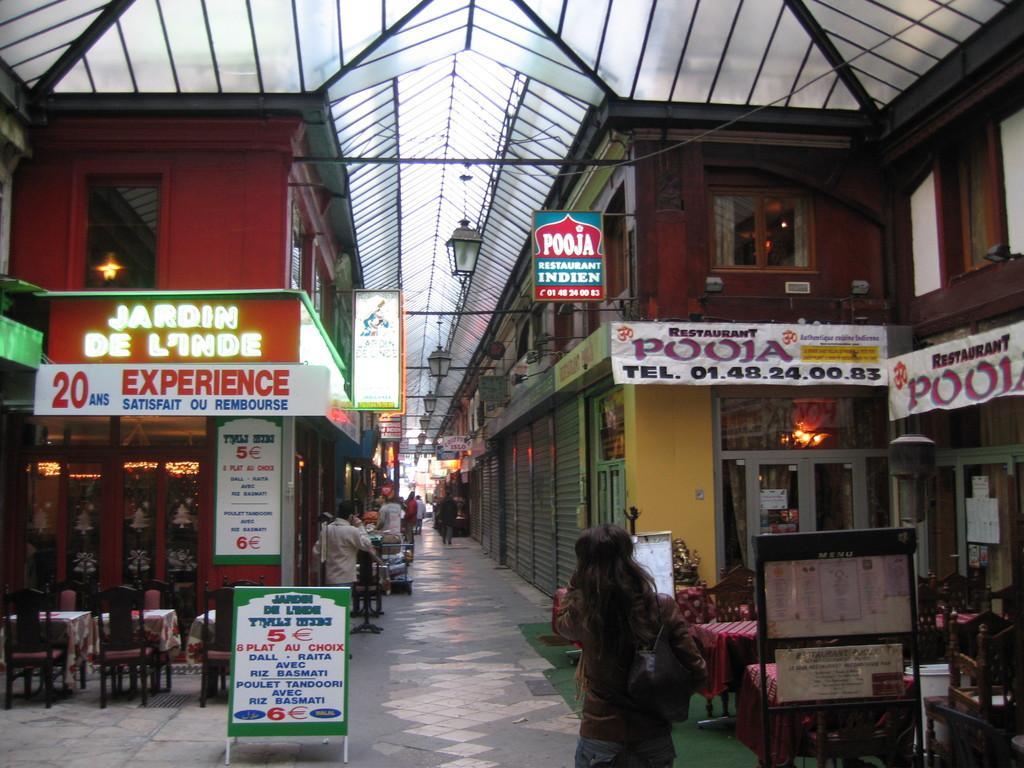Describe this image in one or two sentences. In this image on the right side and left side there are some stores, shutters and some persons are walking and also there are some boards. On the boards there is some text and on the left side there are some chairs and a board, on the board there is text. On the right side there are some chairs, tables and some other objects. In the background there are some persons who are walking, in the center there are some lights and shutters. At the top of the image there is ceiling and some rods and at the bottom there is a walkway. 